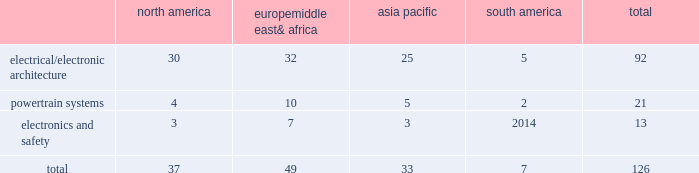Table of contents item 1b .
Unresolved staff comments we have no unresolved sec staff comments to report .
Item 2 .
Properties as of december 31 , 2015 , we owned or leased 126 major manufacturing sites and 14 major technical centers .
A manufacturing site may include multiple plants and may be wholly or partially owned or leased .
We also have many smaller manufacturing sites , sales offices , warehouses , engineering centers , joint ventures and other investments strategically located throughout the world .
We have a presence in 44 countries .
The table shows the regional distribution of our major manufacturing sites by the operating segment that uses such facilities : north america europe , middle east & africa asia pacific south america total .
In addition to these manufacturing sites , we had 14 major technical centers : four in north america ; five in europe , middle east and africa ; four in asia pacific ; and one in south america .
Of our 126 major manufacturing sites and 14 major technical centers , which include facilities owned or leased by our consolidated subsidiaries , 77 are primarily owned and 63 are primarily leased .
We frequently review our real estate portfolio and develop footprint strategies to support our customers 2019 global plans , while at the same time supporting our technical needs and controlling operating expenses .
We believe our evolving portfolio will meet current and anticipated future needs .
Item 3 .
Legal proceedings we are from time to time subject to various actions , claims , suits , government investigations , and other proceedings incidental to our business , including those arising out of alleged defects , breach of contracts , competition and antitrust matters , product warranties , intellectual property matters , personal injury claims and employment-related matters .
It is our opinion that the outcome of such matters will not have a material adverse impact on our consolidated financial position , results of operations , or cash flows .
With respect to warranty matters , although we cannot ensure that the future costs of warranty claims by customers will not be material , we believe our established reserves are adequate to cover potential warranty settlements .
However , the final amounts required to resolve these matters could differ materially from our recorded estimates .
Gm ignition switch recall in the first quarter of 2014 , gm , delphi 2019s largest customer , initiated a product recall related to ignition switches .
Delphi received requests for information from , and cooperated with , various government agencies related to this ignition switch recall .
In addition , delphi was initially named as a co-defendant along with gm ( and in certain cases other parties ) in class action and product liability lawsuits related to this matter .
As of december 31 , 2015 , delphi was not named as a defendant in any class action complaints .
Although no assurances can be made as to the ultimate outcome of these or any other future claims , delphi does not believe a loss is probable and , accordingly , no reserve has been made as of december 31 , 2015 .
Unsecured creditors litigation the fourth amended and restated limited liability partnership agreement of delphi automotive llp ( the 201cfourth llp agreement 201d ) was entered into on july 12 , 2011 by the members of delphi automotive llp in order to position the company for its initial public offering .
Under the terms of the fourth llp agreement , if cumulative distributions to the members of delphi automotive llp under certain provisions of the fourth llp agreement exceed $ 7.2 billion , delphi , as disbursing agent on behalf of dphh , is required to pay to the holders of allowed general unsecured claims against dphh $ 32.50 for every $ 67.50 in excess of $ 7.2 billion distributed to the members , up to a maximum amount of $ 300 million .
In december 2014 , a complaint was filed in the bankruptcy court alleging that the redemption by delphi automotive llp of the membership interests of gm and the pbgc , and the repurchase of shares and payment of dividends by delphi automotive plc , constituted distributions under the terms of the fourth llp agreement approximating $ 7.2 billion .
Delphi considers cumulative .
What is the percentage of powertrain systems sites among all sites? 
Rationale: it is the number of powertrain systems sites divided by all sites , then turned into a percentage .
Computations: (21 / 126)
Answer: 0.16667. 